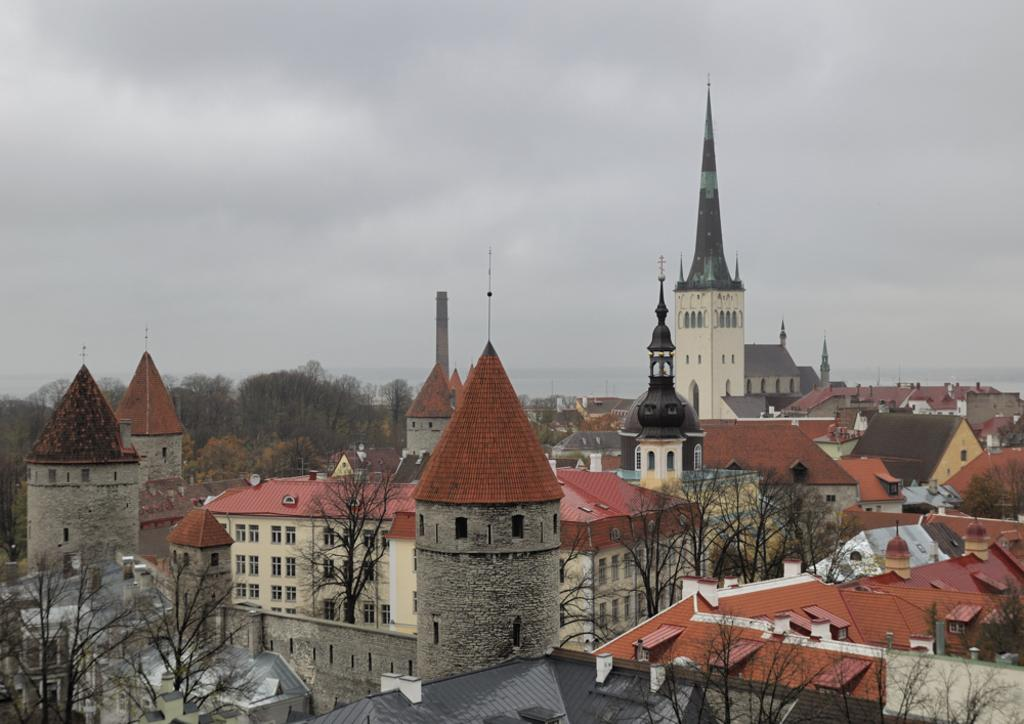What type of location is shown in the image? The image depicts a city. What structures can be seen in the city? There are buildings in the image. Are there any natural elements present in the city? Yes, there are trees in the image. What is visible in the sky in the image? There are clouds visible at the top of the image. Where is the lace factory located in the image? There is no lace factory present in the image. Can you tell me how many tombstones are visible in the cemetery in the image? There is no cemetery present in the image. 